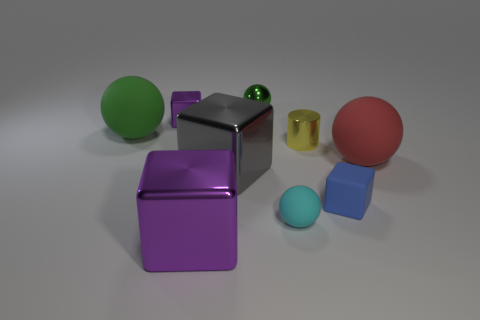Add 1 blue rubber cubes. How many objects exist? 10 Subtract all cylinders. How many objects are left? 8 Add 6 gray matte cubes. How many gray matte cubes exist? 6 Subtract 1 blue blocks. How many objects are left? 8 Subtract all large rubber spheres. Subtract all cylinders. How many objects are left? 6 Add 3 small yellow objects. How many small yellow objects are left? 4 